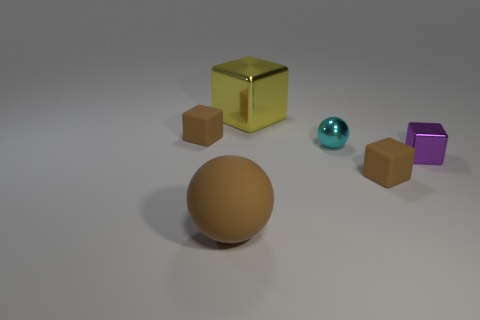There is a cyan ball; what number of spheres are behind it?
Provide a succinct answer. 0. There is a block that is to the left of the small metal sphere and in front of the large yellow shiny thing; what is its size?
Give a very brief answer. Small. Are any rubber things visible?
Provide a short and direct response. Yes. What number of other things are the same size as the purple shiny block?
Give a very brief answer. 3. There is a small thing that is on the left side of the tiny sphere; is its color the same as the metal cube behind the small purple metallic object?
Make the answer very short. No. There is a purple thing that is the same shape as the yellow metal object; what is its size?
Ensure brevity in your answer.  Small. Do the small brown block on the left side of the big shiny cube and the brown object to the right of the cyan ball have the same material?
Your response must be concise. Yes. How many metal things are either big brown balls or tiny brown cubes?
Provide a succinct answer. 0. What material is the small block in front of the shiny cube that is in front of the brown matte cube that is on the left side of the big brown sphere?
Provide a succinct answer. Rubber. There is a rubber object that is to the right of the large shiny object; does it have the same shape as the tiny rubber object on the left side of the yellow cube?
Ensure brevity in your answer.  Yes. 